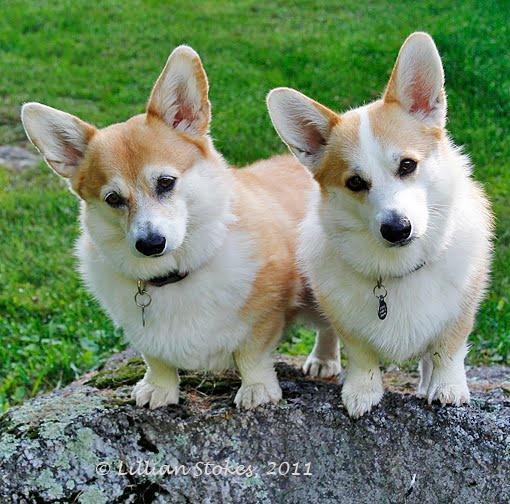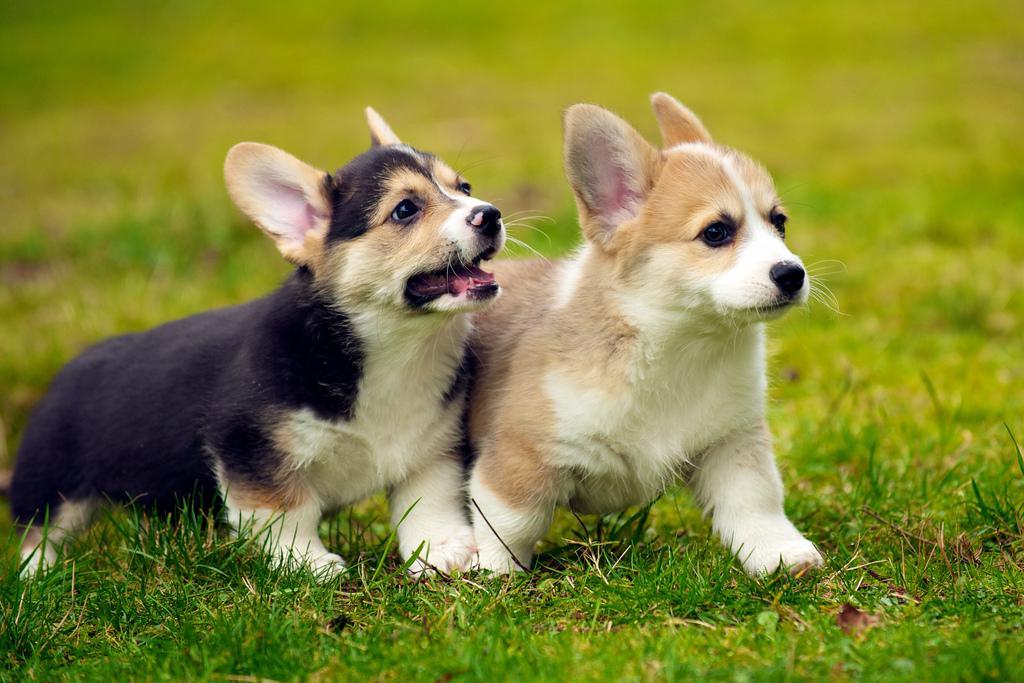The first image is the image on the left, the second image is the image on the right. Given the left and right images, does the statement "Both images in the pair include two corgis next to each other." hold true? Answer yes or no. Yes. The first image is the image on the left, the second image is the image on the right. Considering the images on both sides, is "There are two puppies with ears pointing up as they run right together on grass." valid? Answer yes or no. Yes. 